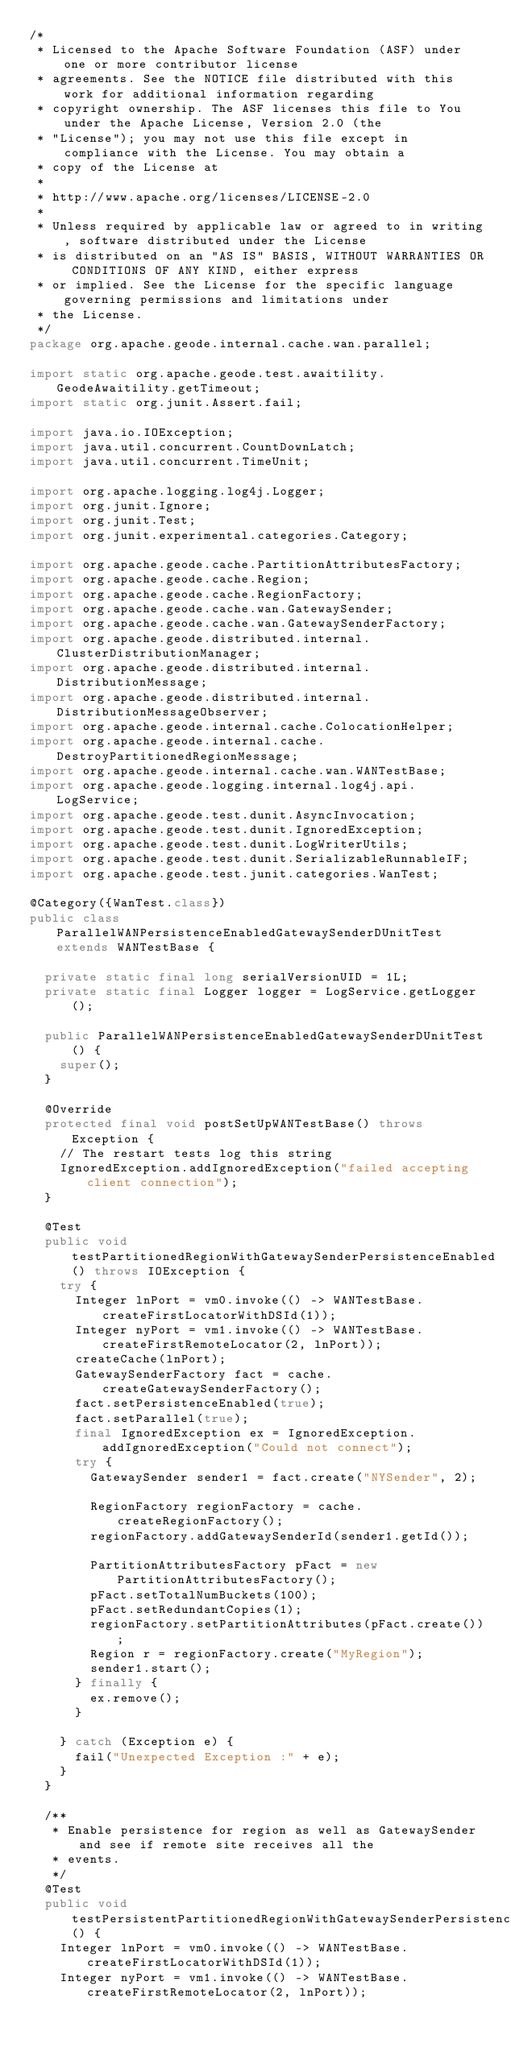<code> <loc_0><loc_0><loc_500><loc_500><_Java_>/*
 * Licensed to the Apache Software Foundation (ASF) under one or more contributor license
 * agreements. See the NOTICE file distributed with this work for additional information regarding
 * copyright ownership. The ASF licenses this file to You under the Apache License, Version 2.0 (the
 * "License"); you may not use this file except in compliance with the License. You may obtain a
 * copy of the License at
 *
 * http://www.apache.org/licenses/LICENSE-2.0
 *
 * Unless required by applicable law or agreed to in writing, software distributed under the License
 * is distributed on an "AS IS" BASIS, WITHOUT WARRANTIES OR CONDITIONS OF ANY KIND, either express
 * or implied. See the License for the specific language governing permissions and limitations under
 * the License.
 */
package org.apache.geode.internal.cache.wan.parallel;

import static org.apache.geode.test.awaitility.GeodeAwaitility.getTimeout;
import static org.junit.Assert.fail;

import java.io.IOException;
import java.util.concurrent.CountDownLatch;
import java.util.concurrent.TimeUnit;

import org.apache.logging.log4j.Logger;
import org.junit.Ignore;
import org.junit.Test;
import org.junit.experimental.categories.Category;

import org.apache.geode.cache.PartitionAttributesFactory;
import org.apache.geode.cache.Region;
import org.apache.geode.cache.RegionFactory;
import org.apache.geode.cache.wan.GatewaySender;
import org.apache.geode.cache.wan.GatewaySenderFactory;
import org.apache.geode.distributed.internal.ClusterDistributionManager;
import org.apache.geode.distributed.internal.DistributionMessage;
import org.apache.geode.distributed.internal.DistributionMessageObserver;
import org.apache.geode.internal.cache.ColocationHelper;
import org.apache.geode.internal.cache.DestroyPartitionedRegionMessage;
import org.apache.geode.internal.cache.wan.WANTestBase;
import org.apache.geode.logging.internal.log4j.api.LogService;
import org.apache.geode.test.dunit.AsyncInvocation;
import org.apache.geode.test.dunit.IgnoredException;
import org.apache.geode.test.dunit.LogWriterUtils;
import org.apache.geode.test.dunit.SerializableRunnableIF;
import org.apache.geode.test.junit.categories.WanTest;

@Category({WanTest.class})
public class ParallelWANPersistenceEnabledGatewaySenderDUnitTest extends WANTestBase {

  private static final long serialVersionUID = 1L;
  private static final Logger logger = LogService.getLogger();

  public ParallelWANPersistenceEnabledGatewaySenderDUnitTest() {
    super();
  }

  @Override
  protected final void postSetUpWANTestBase() throws Exception {
    // The restart tests log this string
    IgnoredException.addIgnoredException("failed accepting client connection");
  }

  @Test
  public void testPartitionedRegionWithGatewaySenderPersistenceEnabled() throws IOException {
    try {
      Integer lnPort = vm0.invoke(() -> WANTestBase.createFirstLocatorWithDSId(1));
      Integer nyPort = vm1.invoke(() -> WANTestBase.createFirstRemoteLocator(2, lnPort));
      createCache(lnPort);
      GatewaySenderFactory fact = cache.createGatewaySenderFactory();
      fact.setPersistenceEnabled(true);
      fact.setParallel(true);
      final IgnoredException ex = IgnoredException.addIgnoredException("Could not connect");
      try {
        GatewaySender sender1 = fact.create("NYSender", 2);

        RegionFactory regionFactory = cache.createRegionFactory();
        regionFactory.addGatewaySenderId(sender1.getId());

        PartitionAttributesFactory pFact = new PartitionAttributesFactory();
        pFact.setTotalNumBuckets(100);
        pFact.setRedundantCopies(1);
        regionFactory.setPartitionAttributes(pFact.create());
        Region r = regionFactory.create("MyRegion");
        sender1.start();
      } finally {
        ex.remove();
      }

    } catch (Exception e) {
      fail("Unexpected Exception :" + e);
    }
  }

  /**
   * Enable persistence for region as well as GatewaySender and see if remote site receives all the
   * events.
   */
  @Test
  public void testPersistentPartitionedRegionWithGatewaySenderPersistenceEnabled() {
    Integer lnPort = vm0.invoke(() -> WANTestBase.createFirstLocatorWithDSId(1));
    Integer nyPort = vm1.invoke(() -> WANTestBase.createFirstRemoteLocator(2, lnPort));
</code> 